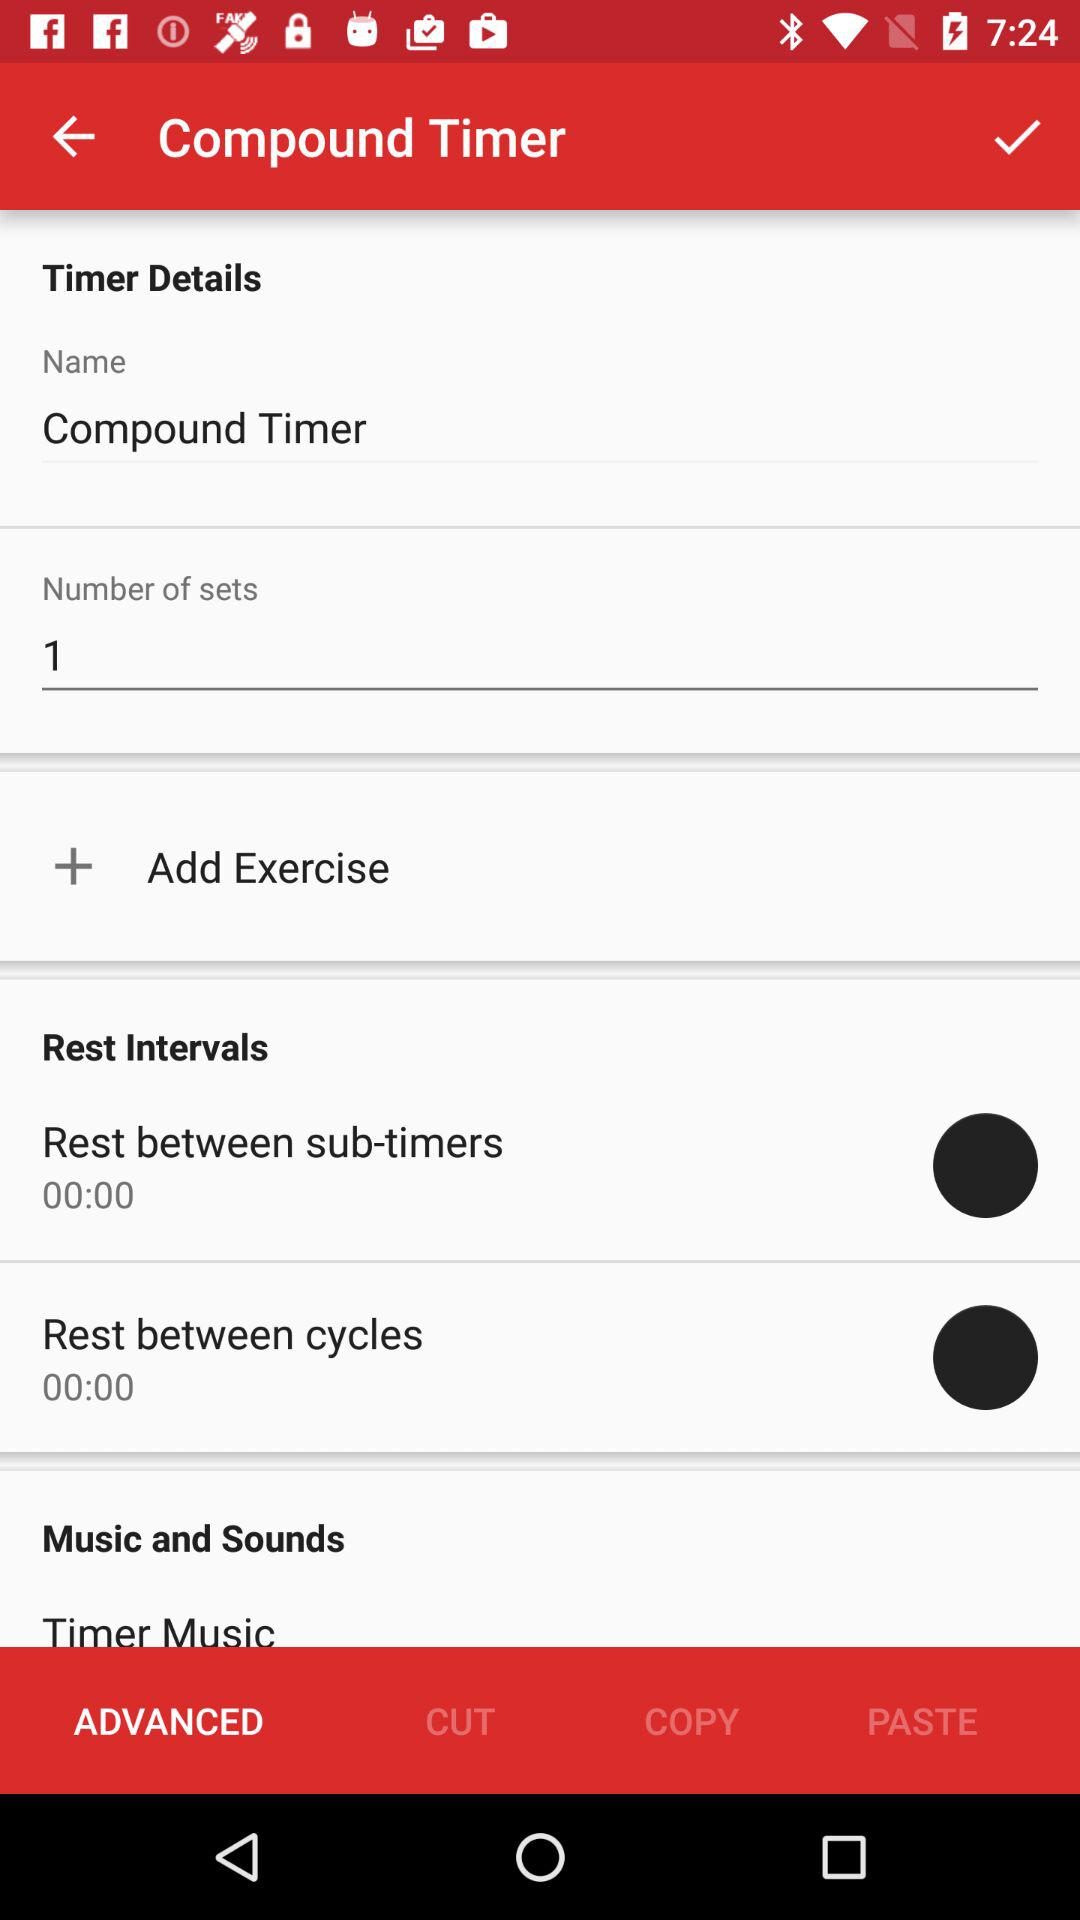What is the duration mentioned in "Rest between sub-timers"? The duration mentioned in "Rest between sub-timers" is 0 minutes. 